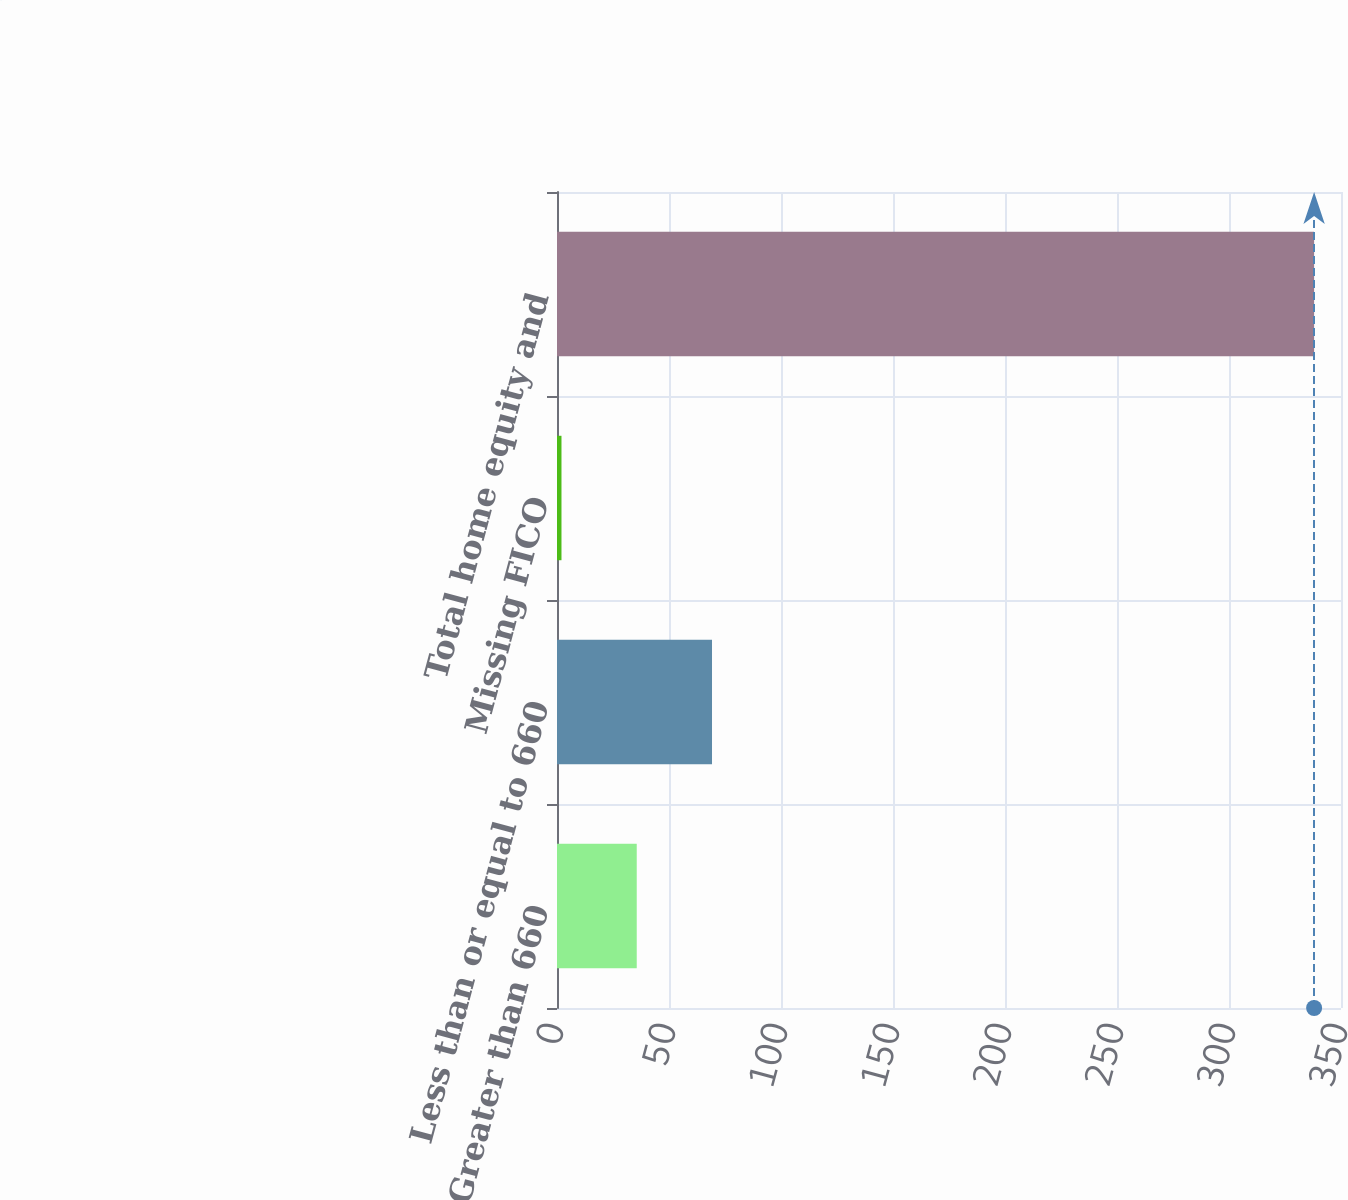Convert chart to OTSL. <chart><loc_0><loc_0><loc_500><loc_500><bar_chart><fcel>Greater than 660<fcel>Less than or equal to 660<fcel>Missing FICO<fcel>Total home equity and<nl><fcel>35.6<fcel>69.2<fcel>2<fcel>338<nl></chart> 